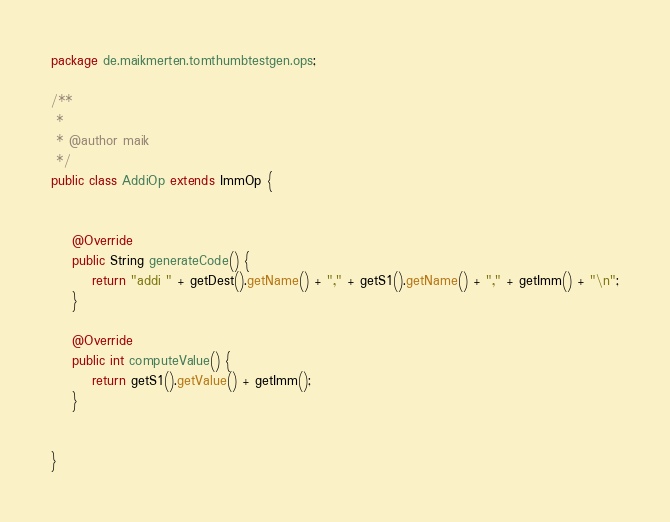Convert code to text. <code><loc_0><loc_0><loc_500><loc_500><_Java_>package de.maikmerten.tomthumbtestgen.ops;

/**
 *
 * @author maik
 */
public class AddiOp extends ImmOp {


	@Override
	public String generateCode() {
		return "addi " + getDest().getName() + "," + getS1().getName() + "," + getImm() + "\n";
	}

	@Override
	public int computeValue() {
		return getS1().getValue() + getImm();
	}
	
	
}
</code> 